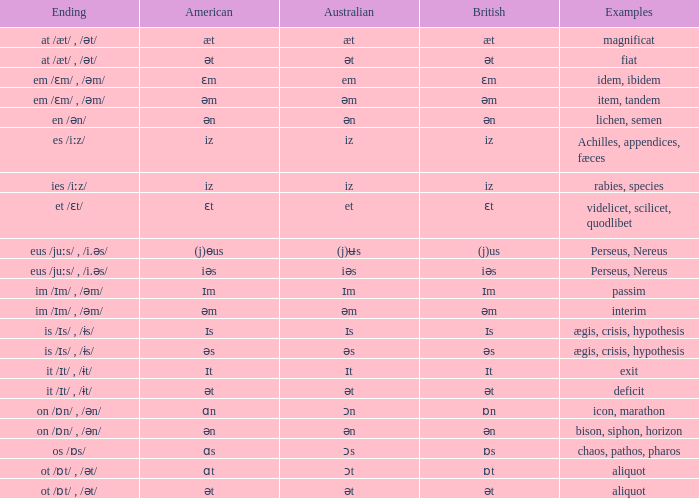Which British has Examples of exit? Ɪt. 